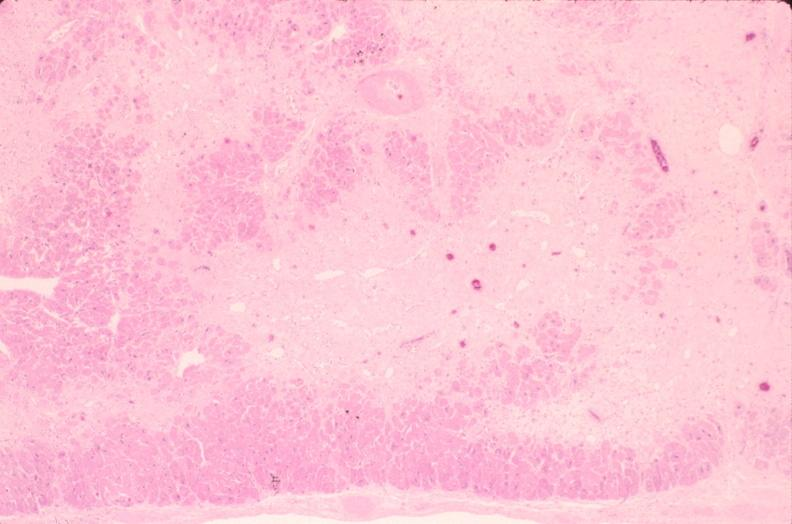does this typical lesion show heart, fibrosis, chronic ischemic heart disease?
Answer the question using a single word or phrase. No 